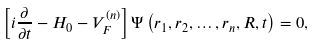<formula> <loc_0><loc_0><loc_500><loc_500>\left [ i \frac { \partial } { \partial t } - H _ { 0 } - V _ { F } ^ { ( n ) } \right ] \Psi \left ( r _ { 1 } , r _ { 2 } , \dots , r _ { n } , R , t \right ) = 0 ,</formula> 